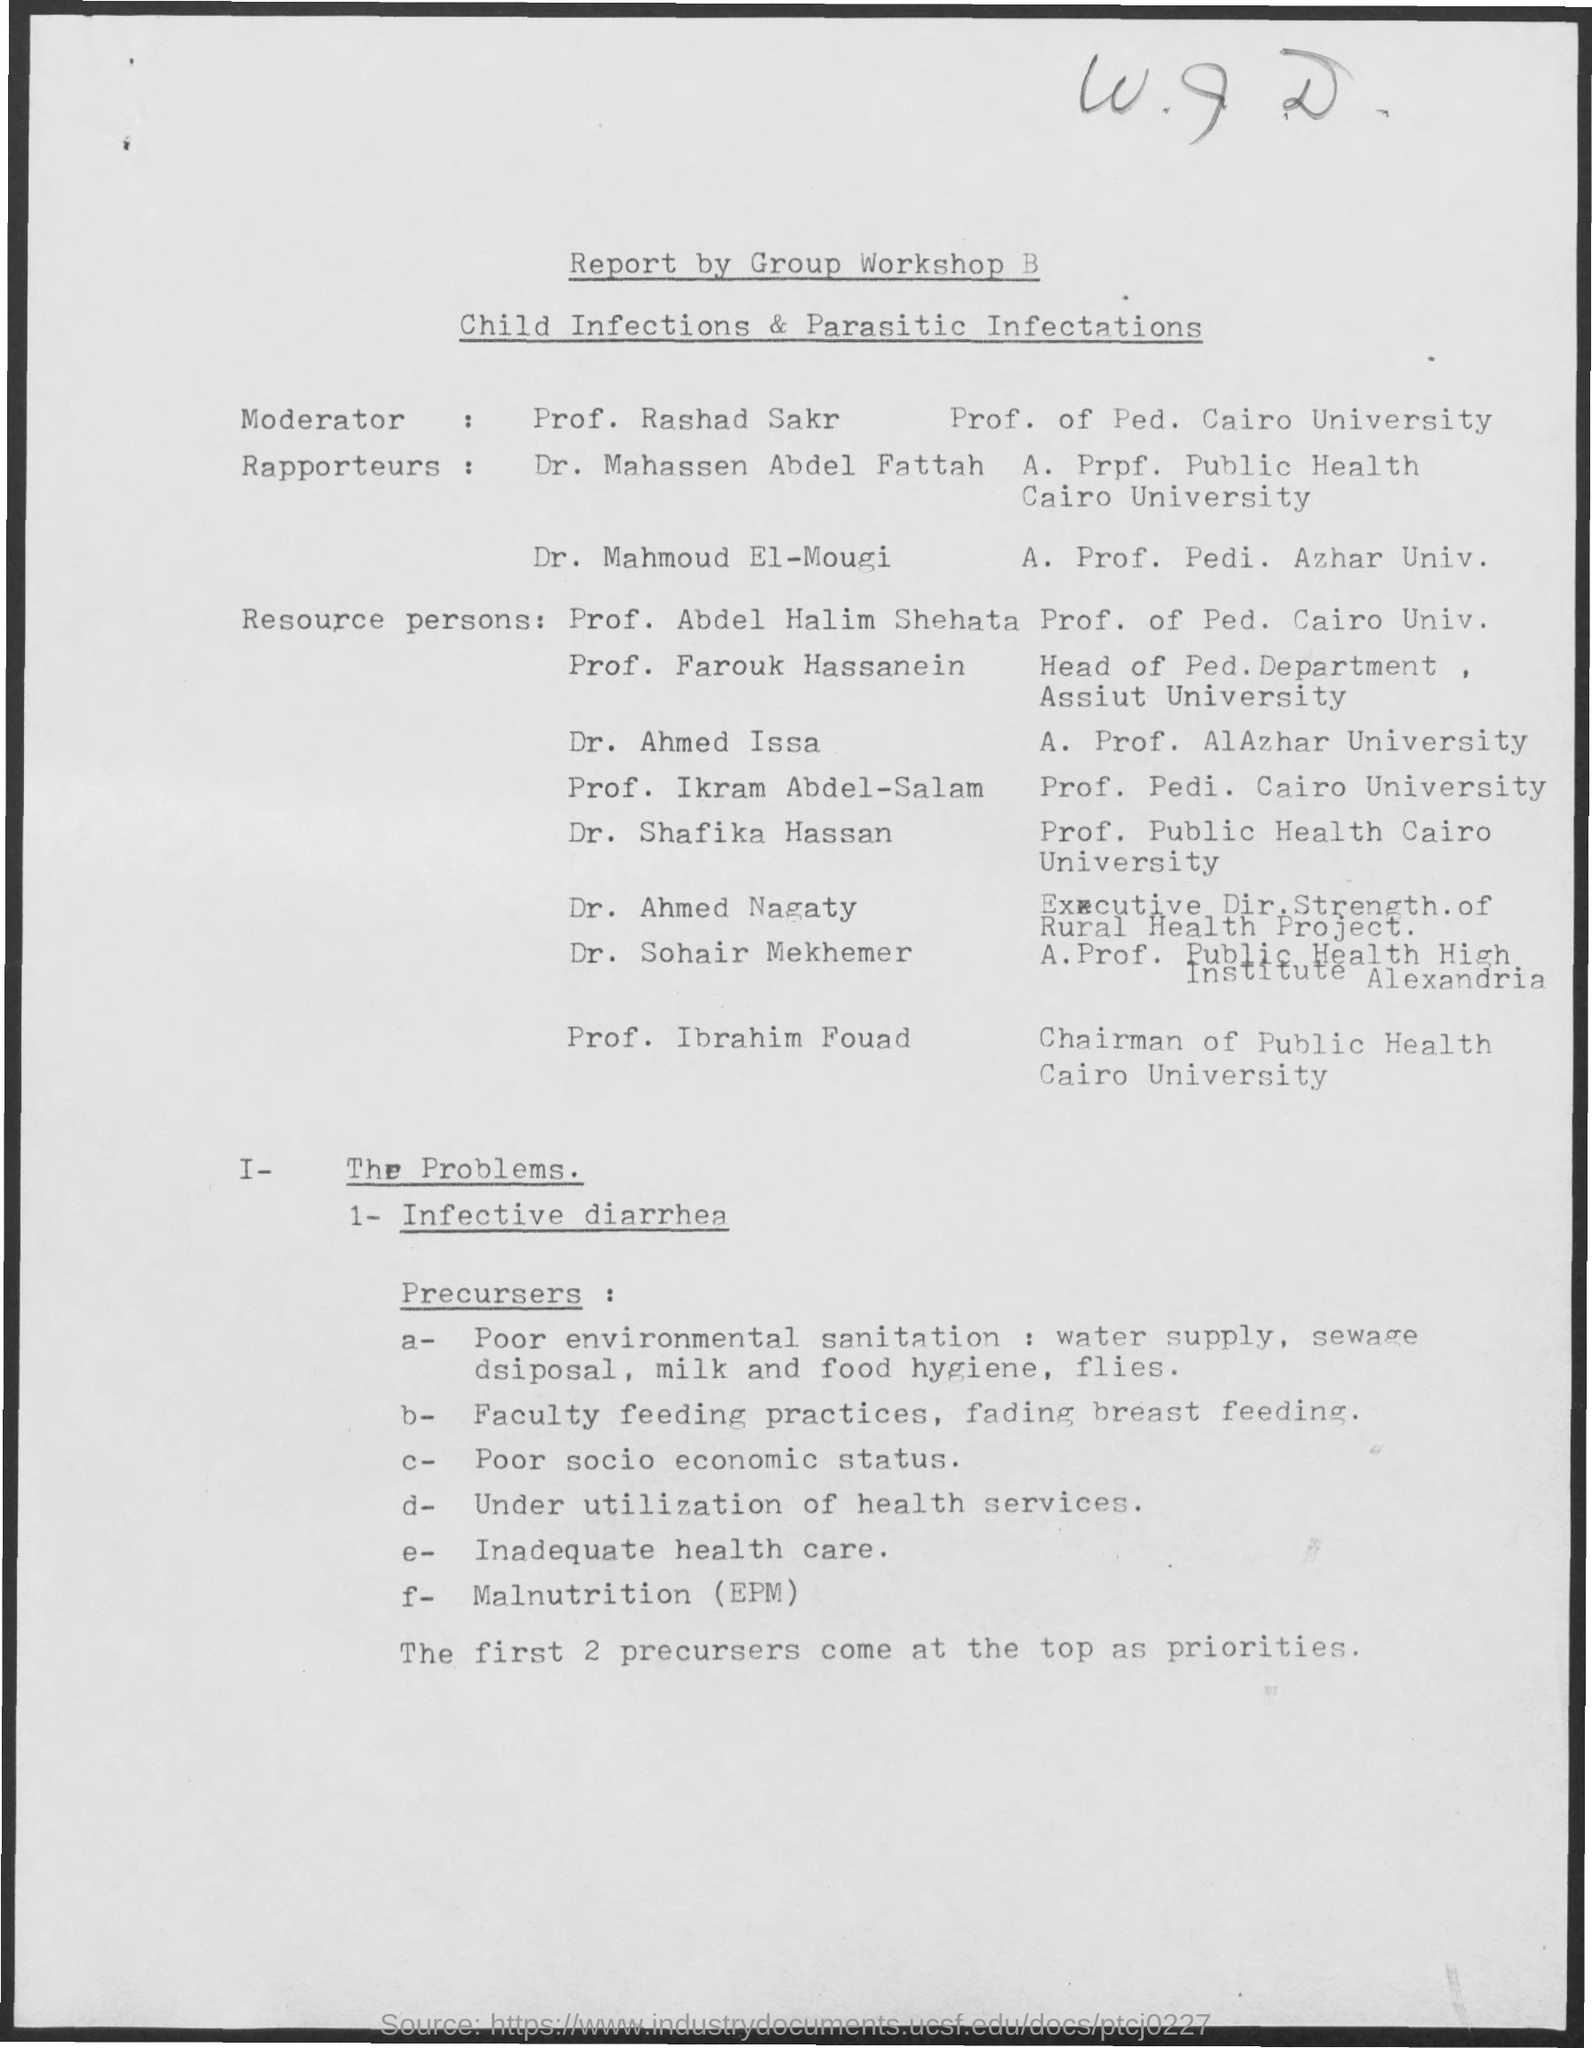Outline some significant characteristics in this image. Prof. Rashad Sakr is the Moderator. 